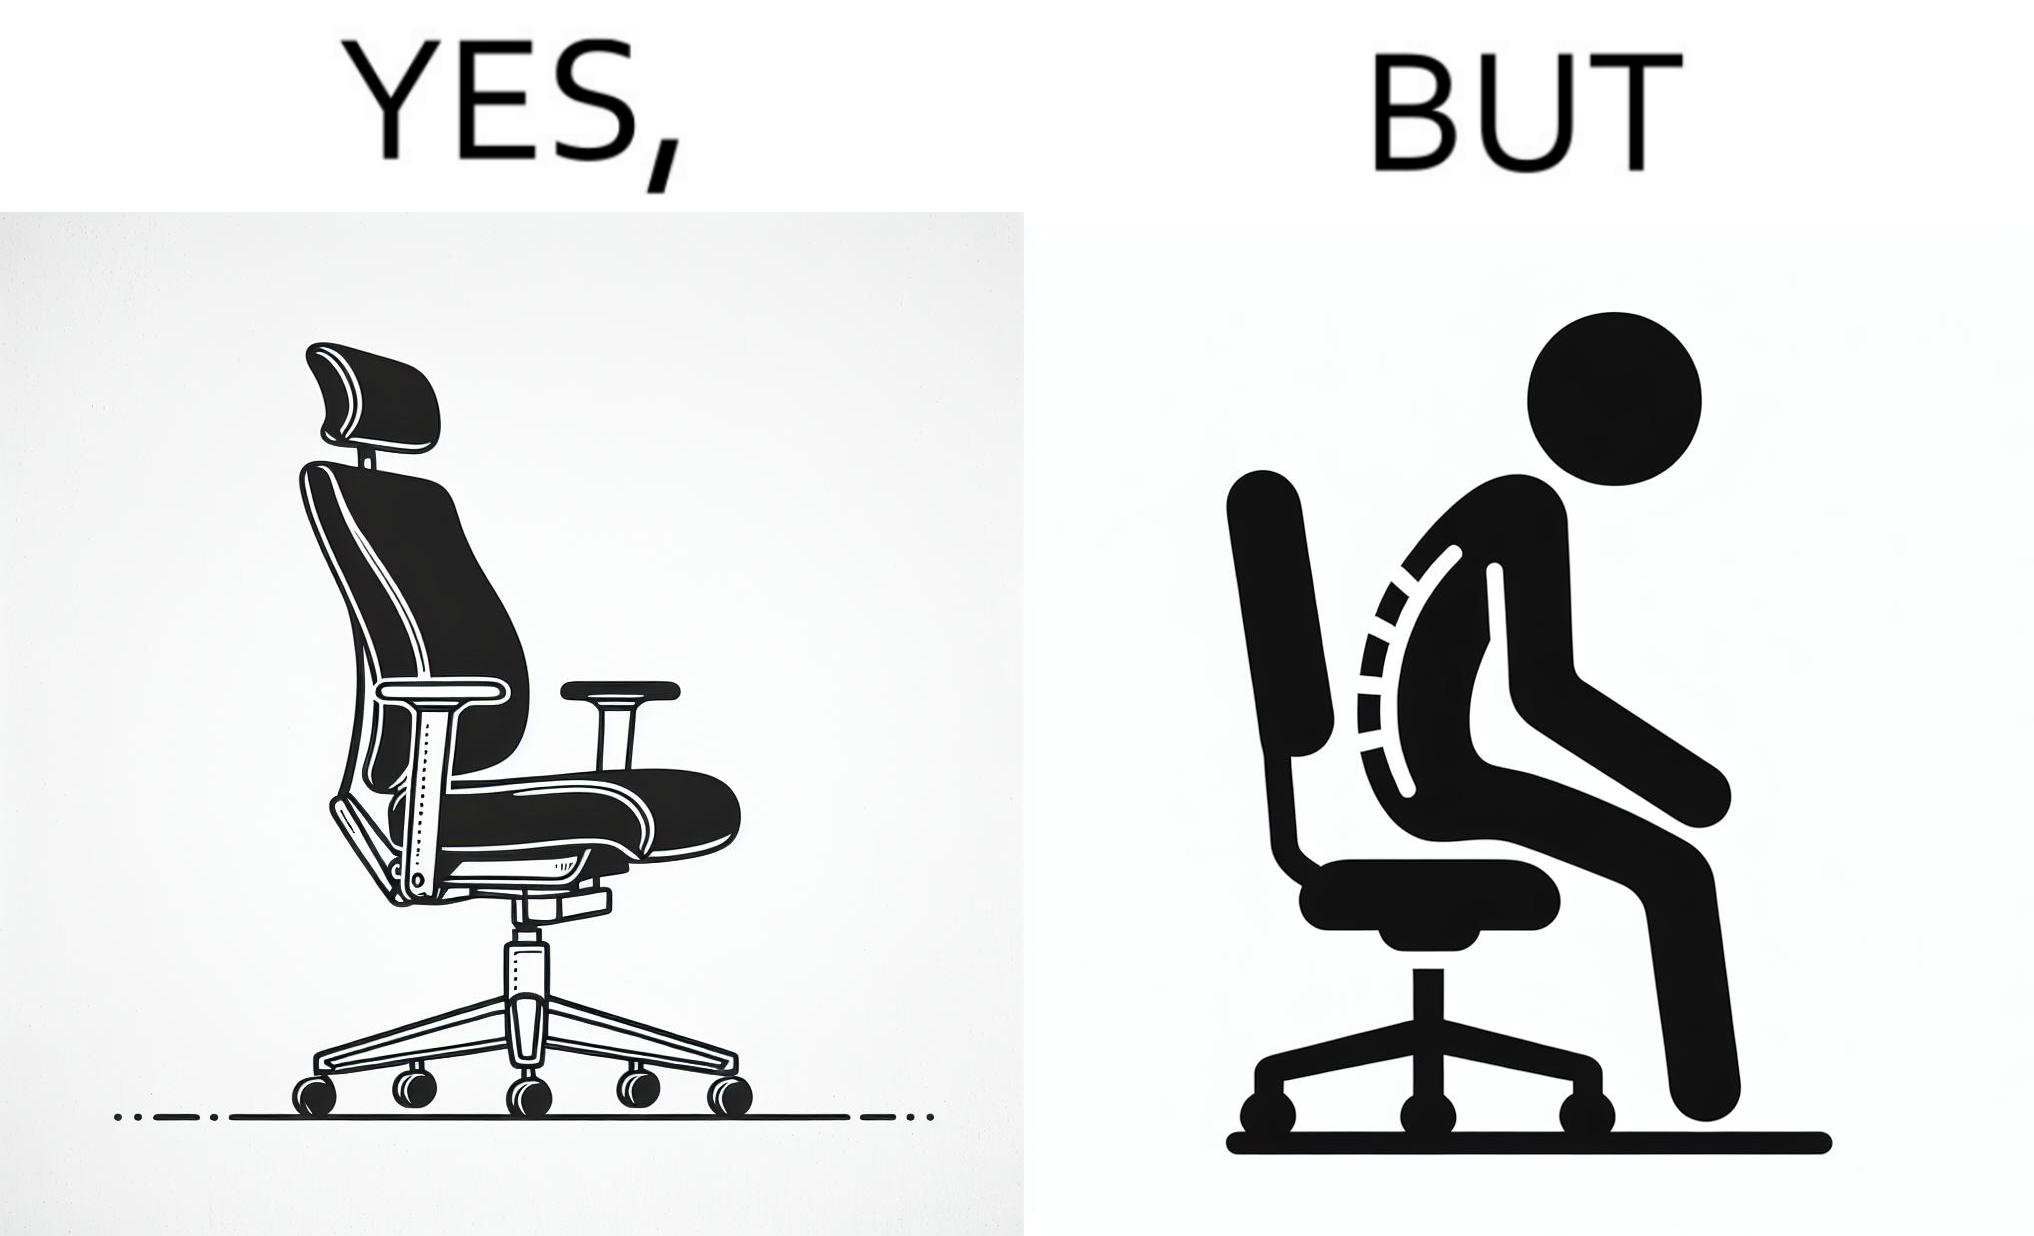What do you see in each half of this image? In the left part of the image: an ergonomic chair. In the right part of the image: a person sitting on a ergonomic chair with a bent spine. 